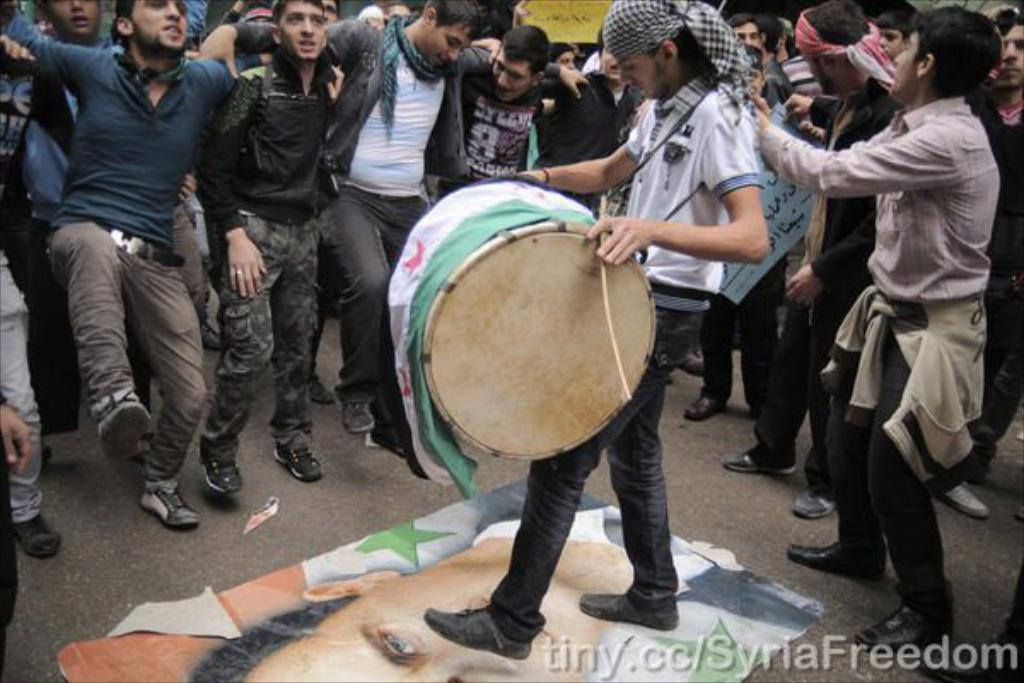What is the main activity being performed in the image? There is a guy playing drums in the image. How is the guy playing the drums? The guy is using sticks to play the drums. What is unique about the guy's position while playing drums? The guy is standing on a photo of a person while playing drums. What can be seen happening in the background of the image? There are people dancing in the background of the image. What type of government is depicted in the image? There is no depiction of a government in the image; it features a guy playing drums, a photo on the floor, and people dancing in the background. 